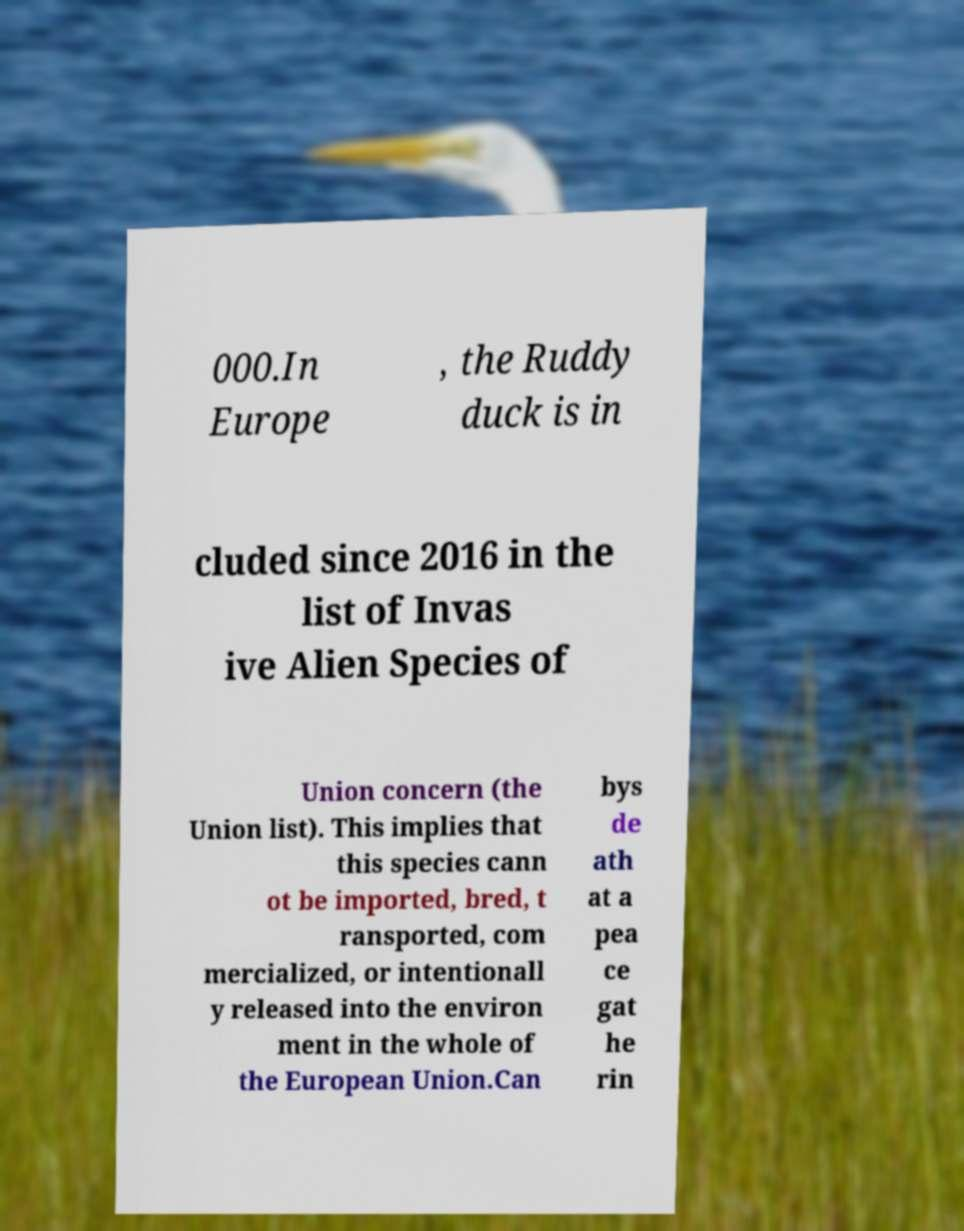For documentation purposes, I need the text within this image transcribed. Could you provide that? 000.In Europe , the Ruddy duck is in cluded since 2016 in the list of Invas ive Alien Species of Union concern (the Union list). This implies that this species cann ot be imported, bred, t ransported, com mercialized, or intentionall y released into the environ ment in the whole of the European Union.Can bys de ath at a pea ce gat he rin 